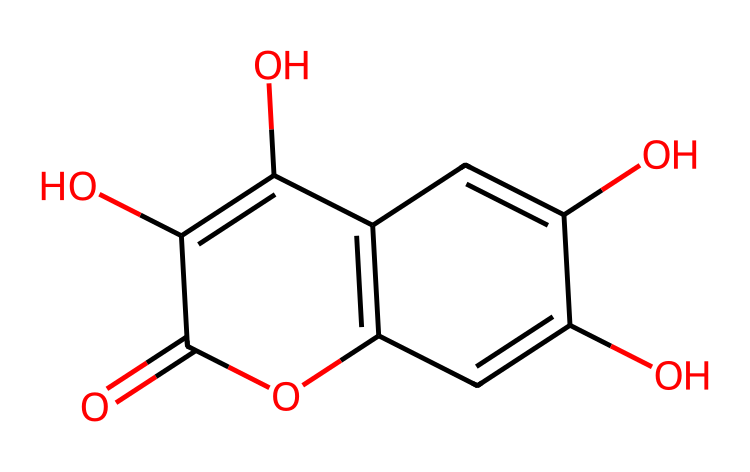What is the molecular formula of this compound? To find the molecular formula, we can count the number of each type of atom in the structure represented by the SMILES. The structure includes 15 carbon atoms, 10 hydrogen atoms, and 5 oxygen atoms. Therefore, the molecular formula is C15H10O5.
Answer: C15H10O5 What functional groups are present in this chemical? By analyzing the structure, we notice the presence of hydroxyl groups (-OH) and carbonyl groups (C=O), which are characteristic functional groups for this compound. Specifically, there are multiple hydroxyl groups and a carbonyl group within the structure.
Answer: hydroxyl and carbonyl How many rings are in the structure? The structure reveals two fused rings in the chemical. We can identify this by looking for multiple cyclic structures, which are linked in a way that forms two interconnected rings.
Answer: two What type of antioxidant properties does this compound likely exhibit? Given the presence of multiple hydroxyl (–OH) groups in the compound, which are known to donate hydrogen atoms, this structure likely exhibits good antioxidant properties by scavenging free radicals. This is typical for flavonoid types of compounds.
Answer: antioxidant Can this compound be classified as a flavonoid? Analyzing the structure, the arrangement of the rings, along with the presence of multiple hydroxyl groups, aligns with typical characteristics of flavonoids. Thus, we can classify this compound as a flavonoid based on these structural features.
Answer: yes 